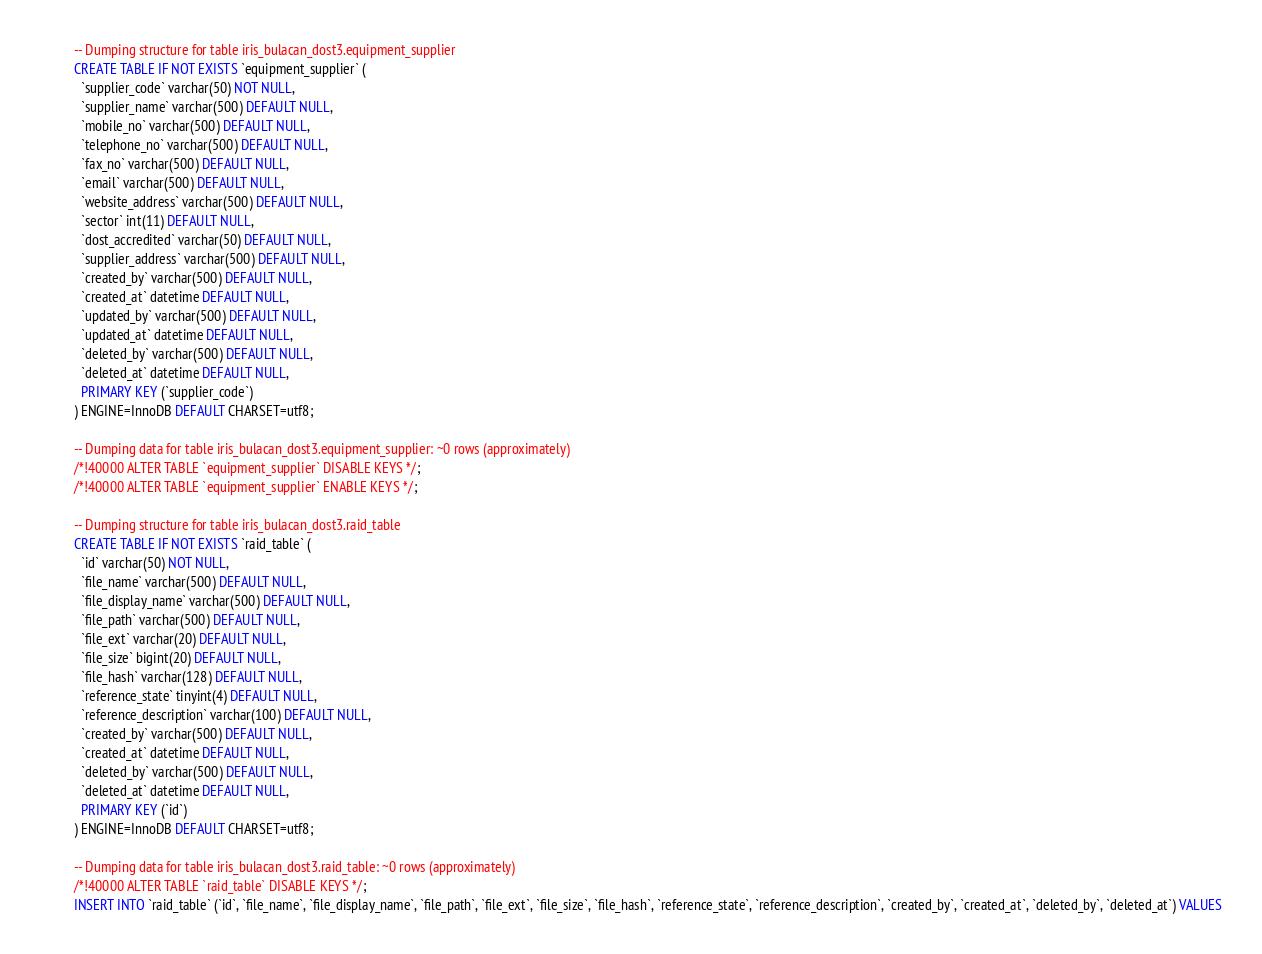Convert code to text. <code><loc_0><loc_0><loc_500><loc_500><_SQL_>
-- Dumping structure for table iris_bulacan_dost3.equipment_supplier
CREATE TABLE IF NOT EXISTS `equipment_supplier` (
  `supplier_code` varchar(50) NOT NULL,
  `supplier_name` varchar(500) DEFAULT NULL,
  `mobile_no` varchar(500) DEFAULT NULL,
  `telephone_no` varchar(500) DEFAULT NULL,
  `fax_no` varchar(500) DEFAULT NULL,
  `email` varchar(500) DEFAULT NULL,
  `website_address` varchar(500) DEFAULT NULL,
  `sector` int(11) DEFAULT NULL,
  `dost_accredited` varchar(50) DEFAULT NULL,
  `supplier_address` varchar(500) DEFAULT NULL,
  `created_by` varchar(500) DEFAULT NULL,
  `created_at` datetime DEFAULT NULL,
  `updated_by` varchar(500) DEFAULT NULL,
  `updated_at` datetime DEFAULT NULL,
  `deleted_by` varchar(500) DEFAULT NULL,
  `deleted_at` datetime DEFAULT NULL,
  PRIMARY KEY (`supplier_code`)
) ENGINE=InnoDB DEFAULT CHARSET=utf8;

-- Dumping data for table iris_bulacan_dost3.equipment_supplier: ~0 rows (approximately)
/*!40000 ALTER TABLE `equipment_supplier` DISABLE KEYS */;
/*!40000 ALTER TABLE `equipment_supplier` ENABLE KEYS */;

-- Dumping structure for table iris_bulacan_dost3.raid_table
CREATE TABLE IF NOT EXISTS `raid_table` (
  `id` varchar(50) NOT NULL,
  `file_name` varchar(500) DEFAULT NULL,
  `file_display_name` varchar(500) DEFAULT NULL,
  `file_path` varchar(500) DEFAULT NULL,
  `file_ext` varchar(20) DEFAULT NULL,
  `file_size` bigint(20) DEFAULT NULL,
  `file_hash` varchar(128) DEFAULT NULL,
  `reference_state` tinyint(4) DEFAULT NULL,
  `reference_description` varchar(100) DEFAULT NULL,
  `created_by` varchar(500) DEFAULT NULL,
  `created_at` datetime DEFAULT NULL,
  `deleted_by` varchar(500) DEFAULT NULL,
  `deleted_at` datetime DEFAULT NULL,
  PRIMARY KEY (`id`)
) ENGINE=InnoDB DEFAULT CHARSET=utf8;

-- Dumping data for table iris_bulacan_dost3.raid_table: ~0 rows (approximately)
/*!40000 ALTER TABLE `raid_table` DISABLE KEYS */;
INSERT INTO `raid_table` (`id`, `file_name`, `file_display_name`, `file_path`, `file_ext`, `file_size`, `file_hash`, `reference_state`, `reference_description`, `created_by`, `created_at`, `deleted_by`, `deleted_at`) VALUES</code> 